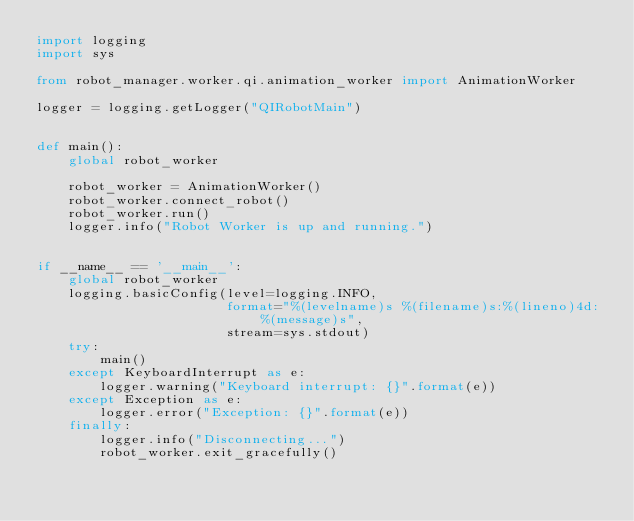Convert code to text. <code><loc_0><loc_0><loc_500><loc_500><_Python_>import logging
import sys

from robot_manager.worker.qi.animation_worker import AnimationWorker

logger = logging.getLogger("QIRobotMain")


def main():
    global robot_worker

    robot_worker = AnimationWorker()
    robot_worker.connect_robot()
    robot_worker.run()
    logger.info("Robot Worker is up and running.")


if __name__ == '__main__':
    global robot_worker
    logging.basicConfig(level=logging.INFO,
                        format="%(levelname)s %(filename)s:%(lineno)4d: %(message)s",
                        stream=sys.stdout)
    try:
        main()
    except KeyboardInterrupt as e:
        logger.warning("Keyboard interrupt: {}".format(e))
    except Exception as e:
        logger.error("Exception: {}".format(e))
    finally:
        logger.info("Disconnecting...")
        robot_worker.exit_gracefully()
</code> 